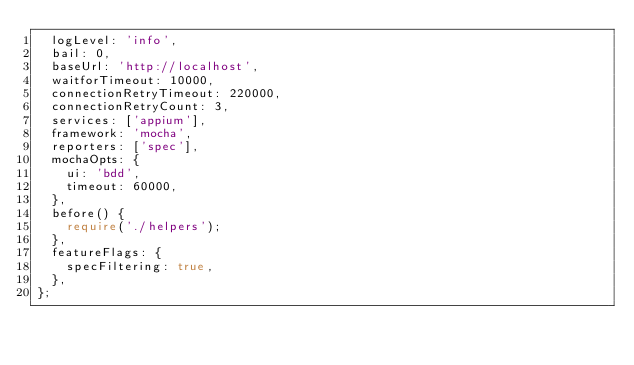Convert code to text. <code><loc_0><loc_0><loc_500><loc_500><_TypeScript_>  logLevel: 'info',
  bail: 0,
  baseUrl: 'http://localhost',
  waitforTimeout: 10000,
  connectionRetryTimeout: 220000,
  connectionRetryCount: 3,
  services: ['appium'],
  framework: 'mocha',
  reporters: ['spec'],
  mochaOpts: {
    ui: 'bdd',
    timeout: 60000,
  },
  before() {
    require('./helpers');
  },
  featureFlags: {
    specFiltering: true,
  },
};
</code> 